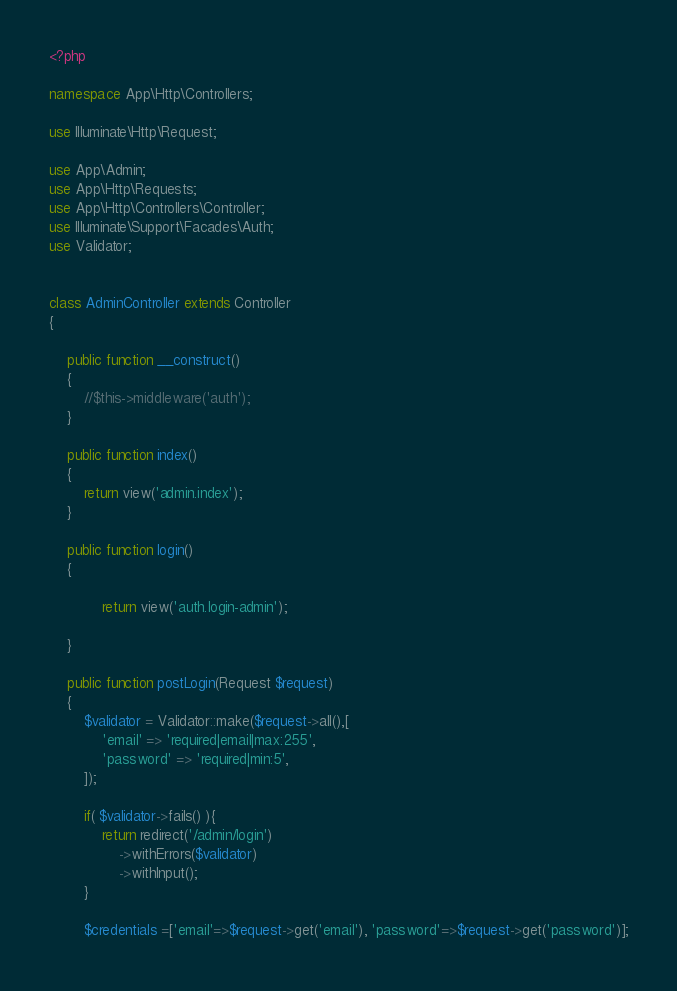Convert code to text. <code><loc_0><loc_0><loc_500><loc_500><_PHP_><?php

namespace App\Http\Controllers;

use Illuminate\Http\Request;

use App\Admin;
use App\Http\Requests;
use App\Http\Controllers\Controller;
use Illuminate\Support\Facades\Auth;
use Validator;


class AdminController extends Controller
{

    public function __construct()
    {
        //$this->middleware('auth');
    }

    public function index()
    {
        return view('admin.index');
    }

    public function login()
    {

            return view('auth.login-admin');

    }

    public function postLogin(Request $request)
    {
        $validator = Validator::make($request->all(),[
            'email' => 'required|email|max:255',
            'password' => 'required|min:5',
        ]);

        if( $validator->fails() ){
            return redirect('/admin/login')
                ->withErrors($validator)
                ->withInput();
        }

        $credentials =['email'=>$request->get('email'), 'password'=>$request->get('password')];
</code> 